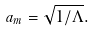<formula> <loc_0><loc_0><loc_500><loc_500>a _ { m } = \sqrt { 1 / \Lambda } .</formula> 